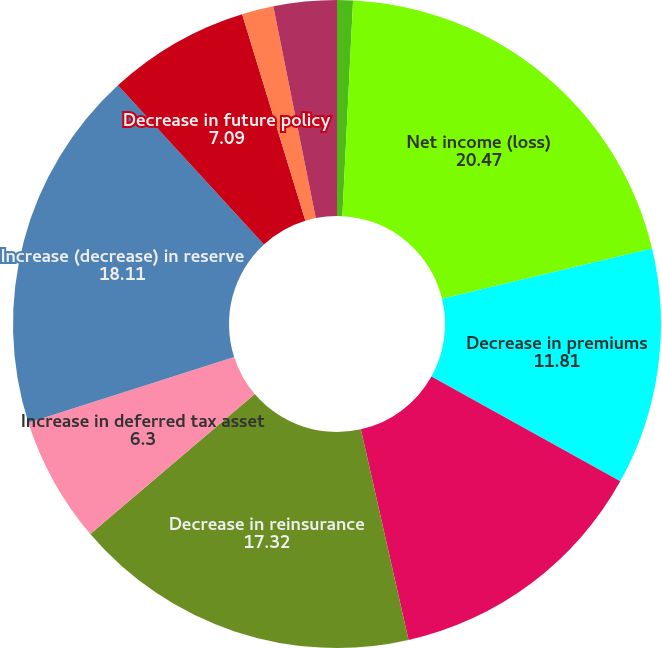Convert chart to OTSL. <chart><loc_0><loc_0><loc_500><loc_500><pie_chart><fcel>(Dollars in thousands)<fcel>Net income (loss)<fcel>Decrease in premiums<fcel>Increase in funds held by<fcel>Decrease in reinsurance<fcel>Increase in deferred tax asset<fcel>Increase (decrease) in reserve<fcel>Decrease in future policy<fcel>Change in other assets and<fcel>Non-cash compensation expense<nl><fcel>0.79%<fcel>20.47%<fcel>11.81%<fcel>13.39%<fcel>17.32%<fcel>6.3%<fcel>18.11%<fcel>7.09%<fcel>1.58%<fcel>3.15%<nl></chart> 